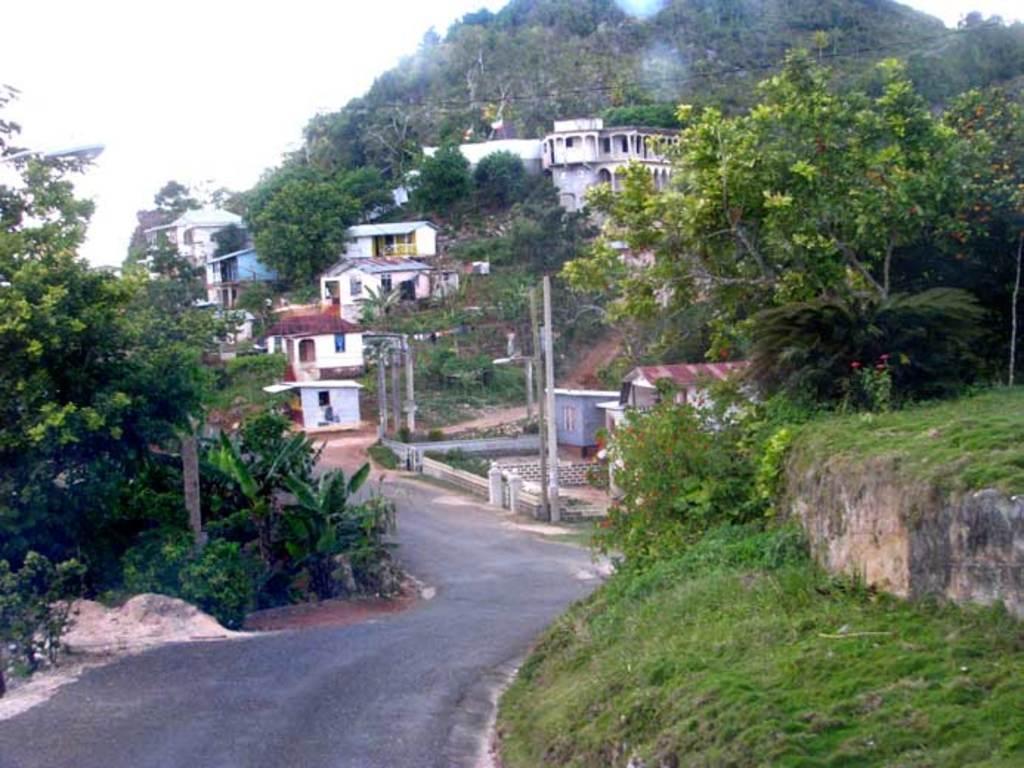In one or two sentences, can you explain what this image depicts? In the picture I can see the road. There are trees on both sides of the road. I can see the green grass on the bottom right side of the picture. In the background, I can see the houses and trees. 